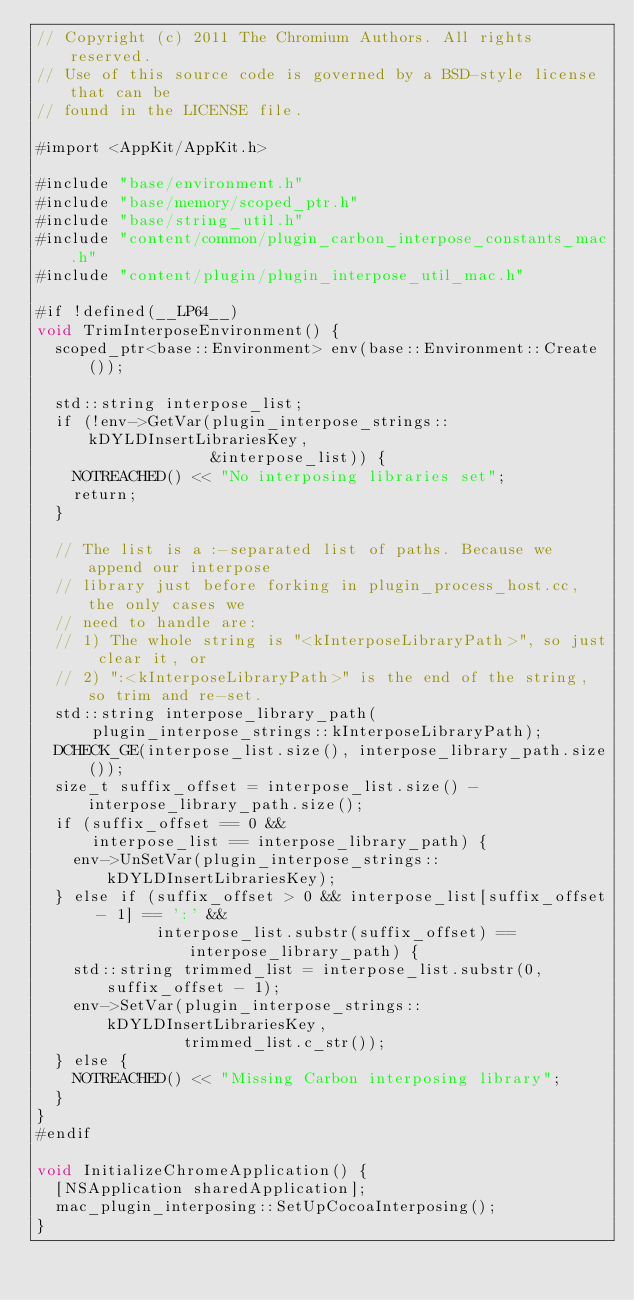Convert code to text. <code><loc_0><loc_0><loc_500><loc_500><_ObjectiveC_>// Copyright (c) 2011 The Chromium Authors. All rights reserved.
// Use of this source code is governed by a BSD-style license that can be
// found in the LICENSE file.

#import <AppKit/AppKit.h>

#include "base/environment.h"
#include "base/memory/scoped_ptr.h"
#include "base/string_util.h"
#include "content/common/plugin_carbon_interpose_constants_mac.h"
#include "content/plugin/plugin_interpose_util_mac.h"

#if !defined(__LP64__)
void TrimInterposeEnvironment() {
  scoped_ptr<base::Environment> env(base::Environment::Create());

  std::string interpose_list;
  if (!env->GetVar(plugin_interpose_strings::kDYLDInsertLibrariesKey,
                   &interpose_list)) {
    NOTREACHED() << "No interposing libraries set";
    return;
  }

  // The list is a :-separated list of paths. Because we append our interpose
  // library just before forking in plugin_process_host.cc, the only cases we
  // need to handle are:
  // 1) The whole string is "<kInterposeLibraryPath>", so just clear it, or
  // 2) ":<kInterposeLibraryPath>" is the end of the string, so trim and re-set.
  std::string interpose_library_path(
      plugin_interpose_strings::kInterposeLibraryPath);
  DCHECK_GE(interpose_list.size(), interpose_library_path.size());
  size_t suffix_offset = interpose_list.size() - interpose_library_path.size();
  if (suffix_offset == 0 &&
      interpose_list == interpose_library_path) {
    env->UnSetVar(plugin_interpose_strings::kDYLDInsertLibrariesKey);
  } else if (suffix_offset > 0 && interpose_list[suffix_offset - 1] == ':' &&
             interpose_list.substr(suffix_offset) == interpose_library_path) {
    std::string trimmed_list = interpose_list.substr(0, suffix_offset - 1);
    env->SetVar(plugin_interpose_strings::kDYLDInsertLibrariesKey,
                trimmed_list.c_str());
  } else {
    NOTREACHED() << "Missing Carbon interposing library";
  }
}
#endif

void InitializeChromeApplication() {
  [NSApplication sharedApplication];
  mac_plugin_interposing::SetUpCocoaInterposing();
}
</code> 